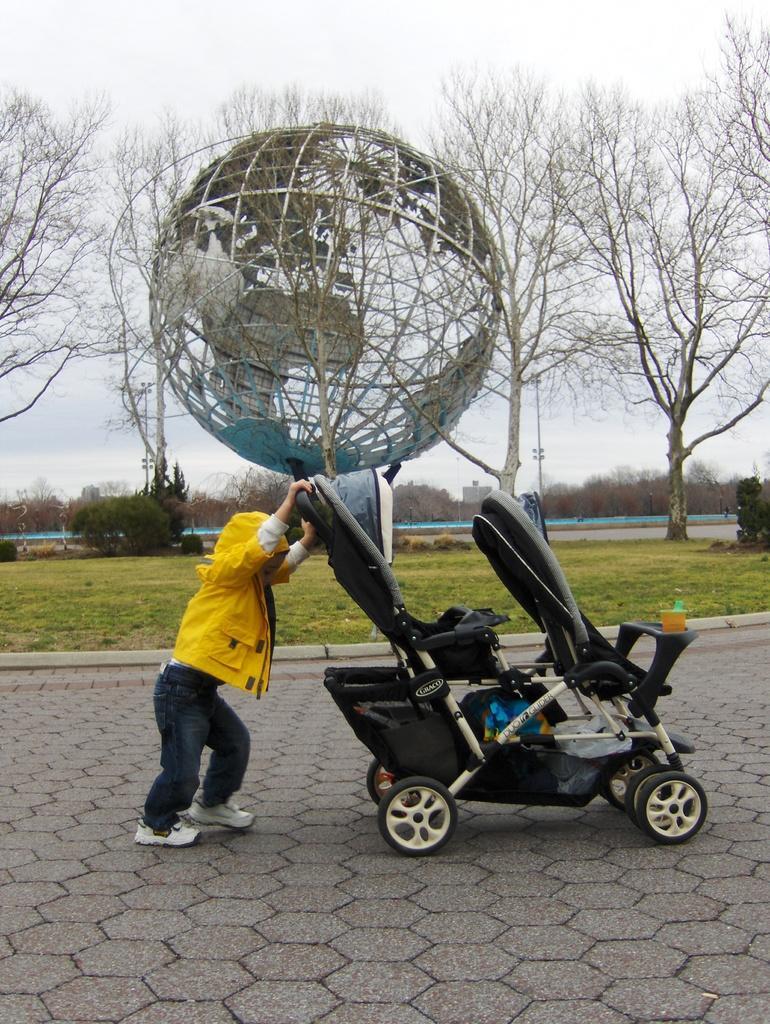How would you summarize this image in a sentence or two? In this image we can see a little boy pushing a Walker on the path of a ground. On the ground there are trees, grass and plants. In the background of the image there is a sky. 